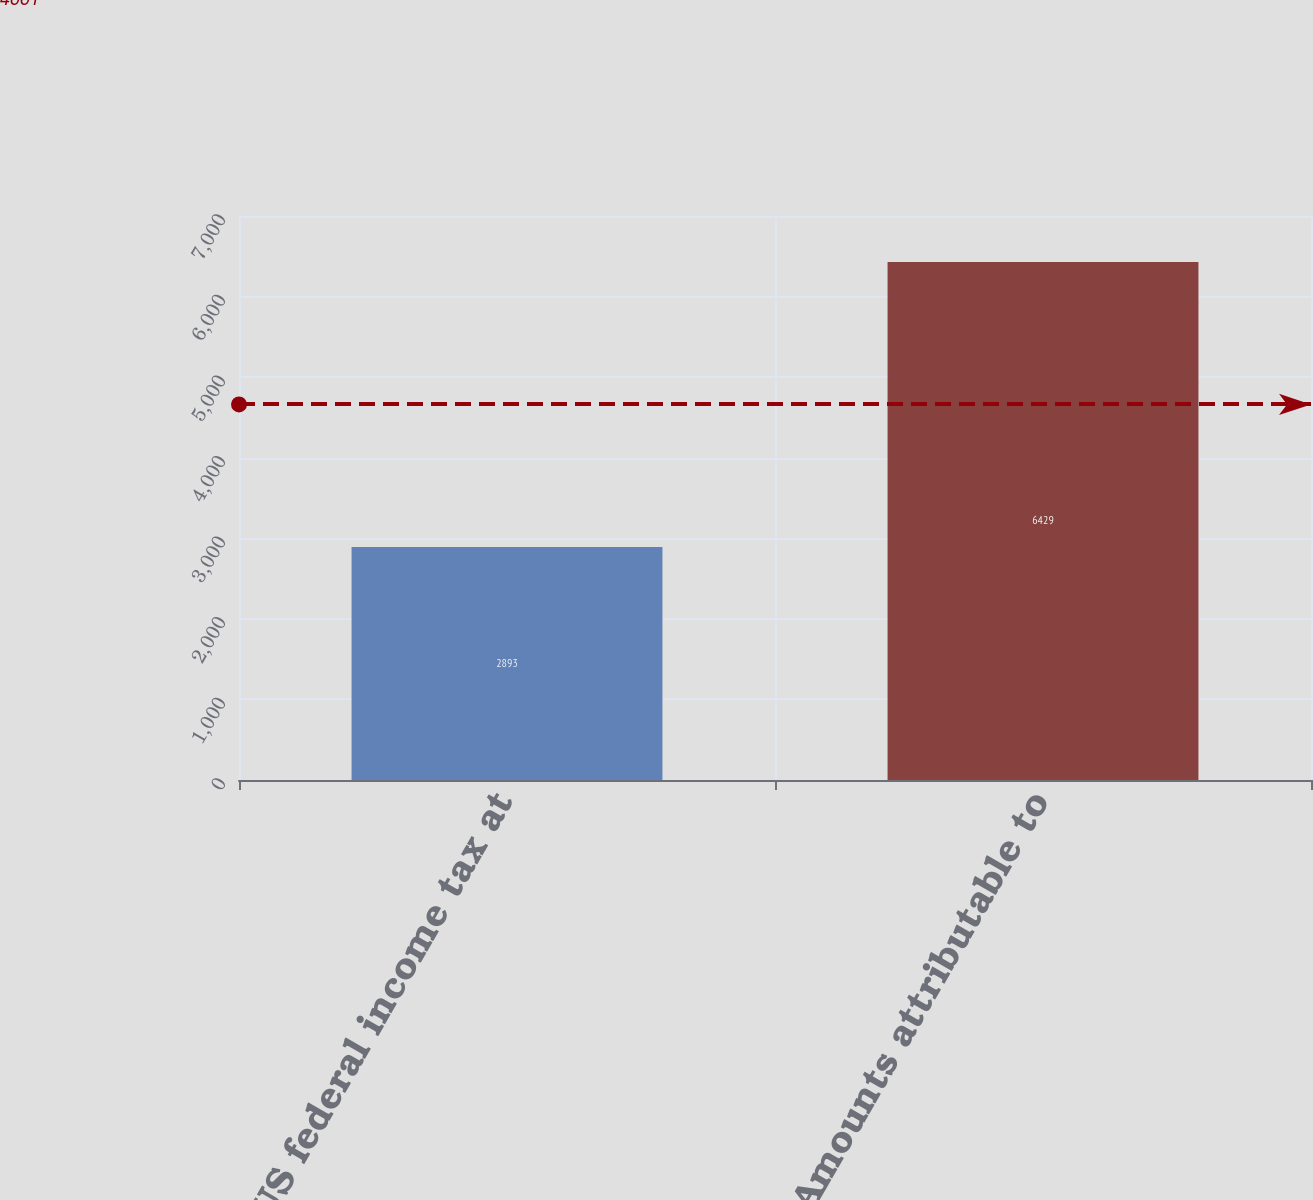<chart> <loc_0><loc_0><loc_500><loc_500><bar_chart><fcel>US federal income tax at<fcel>Amounts attributable to<nl><fcel>2893<fcel>6429<nl></chart> 